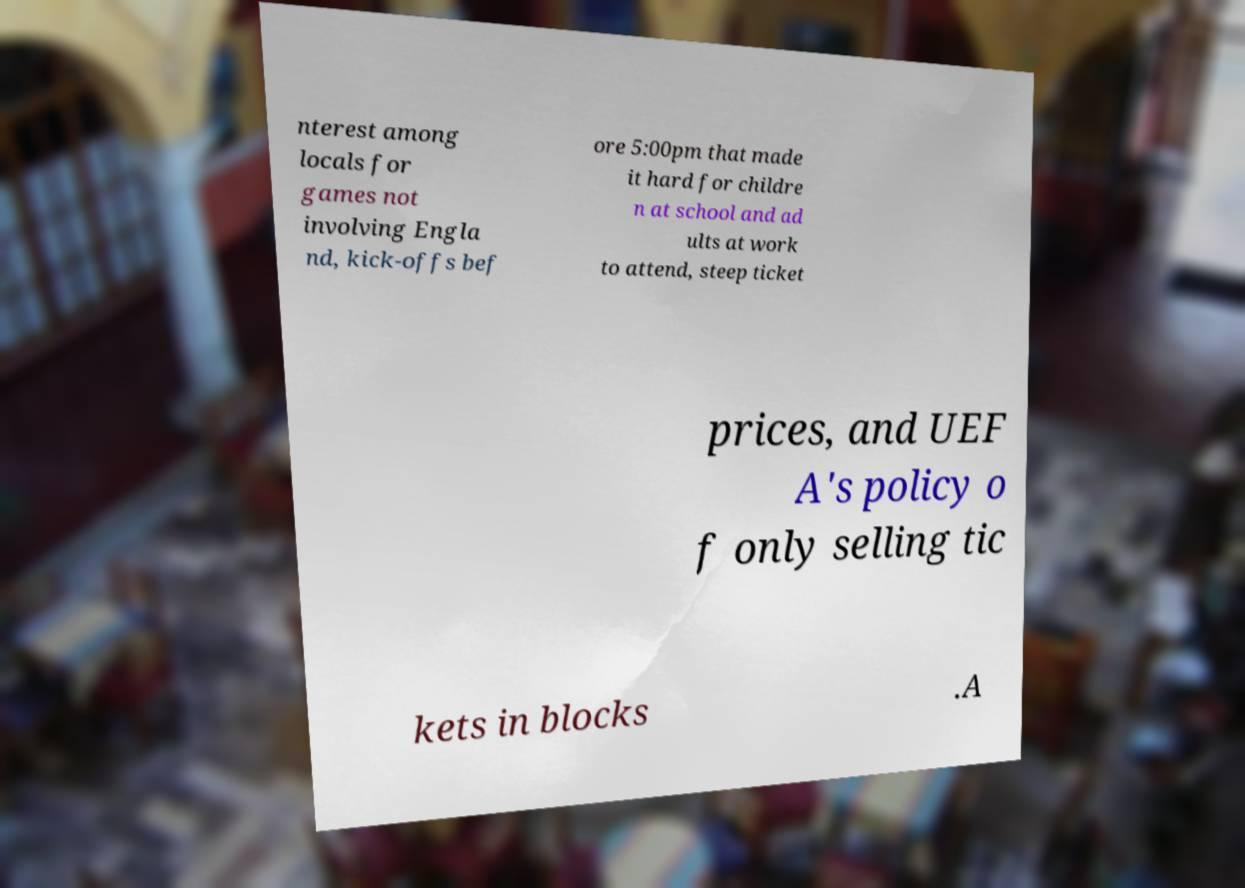Could you extract and type out the text from this image? nterest among locals for games not involving Engla nd, kick-offs bef ore 5:00pm that made it hard for childre n at school and ad ults at work to attend, steep ticket prices, and UEF A's policy o f only selling tic kets in blocks .A 